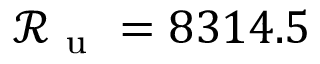Convert formula to latex. <formula><loc_0><loc_0><loc_500><loc_500>\mathcal { R } _ { u } = 8 3 1 4 . 5</formula> 